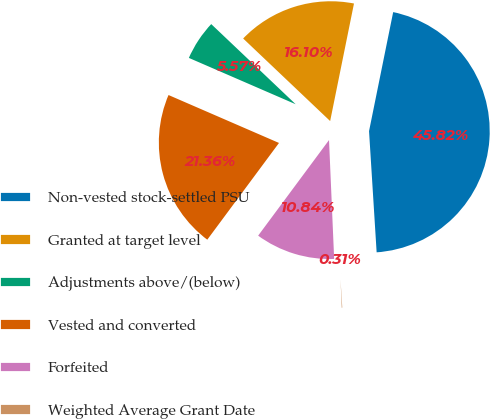Convert chart to OTSL. <chart><loc_0><loc_0><loc_500><loc_500><pie_chart><fcel>Non-vested stock-settled PSU<fcel>Granted at target level<fcel>Adjustments above/(below)<fcel>Vested and converted<fcel>Forfeited<fcel>Weighted Average Grant Date<nl><fcel>45.82%<fcel>16.1%<fcel>5.57%<fcel>21.36%<fcel>10.84%<fcel>0.31%<nl></chart> 